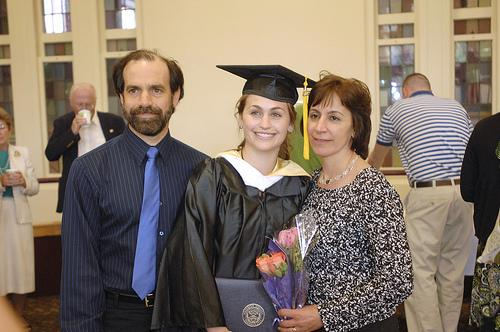Identify the person wearing a silver necklace and describe their appearance. The woman on the right is wearing a silver necklace. She has short brown hair and is wearing a black and white patterned blouse. Mention one prominent event happening in the photograph. A young woman is wearing a graduation gown and holding a diploma as she celebrates her achievement. State an observation about the woman wearing glasses and a white dress. There is no woman wearing glasses and a white dress in the image. In one sentence, describe one remarkable feature of the person wearing a blue tie. The man wearing a blue tie has a beard and is wearing a blue-striped shirt. Express in a poetic manner the visual of a group of flowers. A cluster of delicate pink roses, cradled in the graduate's arms, adds a touch of natural beauty to the celebration. Describe the nature of the man drinking from a cup. The older man in the background, sipping from a white cup, appears contemplative amidst the festive surroundings. Explain the attire of the person with a graduation cap and what it might symbolize. The young woman wears a black graduation cap and gown, symbolizing her academic achievements and the culmination of her studies. List the primary elements in the image and their notable characteristics. The image features a young woman in a graduation gown holding a diploma and flowers, a man in a blue tie and striped shirt, and a woman in a patterned blouse. There's also an older man in the background drinking from a cup. Briefly describe the person wearing a green coat in the image. There is no person wearing a green coat in the image. Mention an accessory seen on a subject in the image and describe the subject's characteristics. The man wearing a blue tie also has a belt, and he is dressed in a blue-striped shirt and dark pants. 